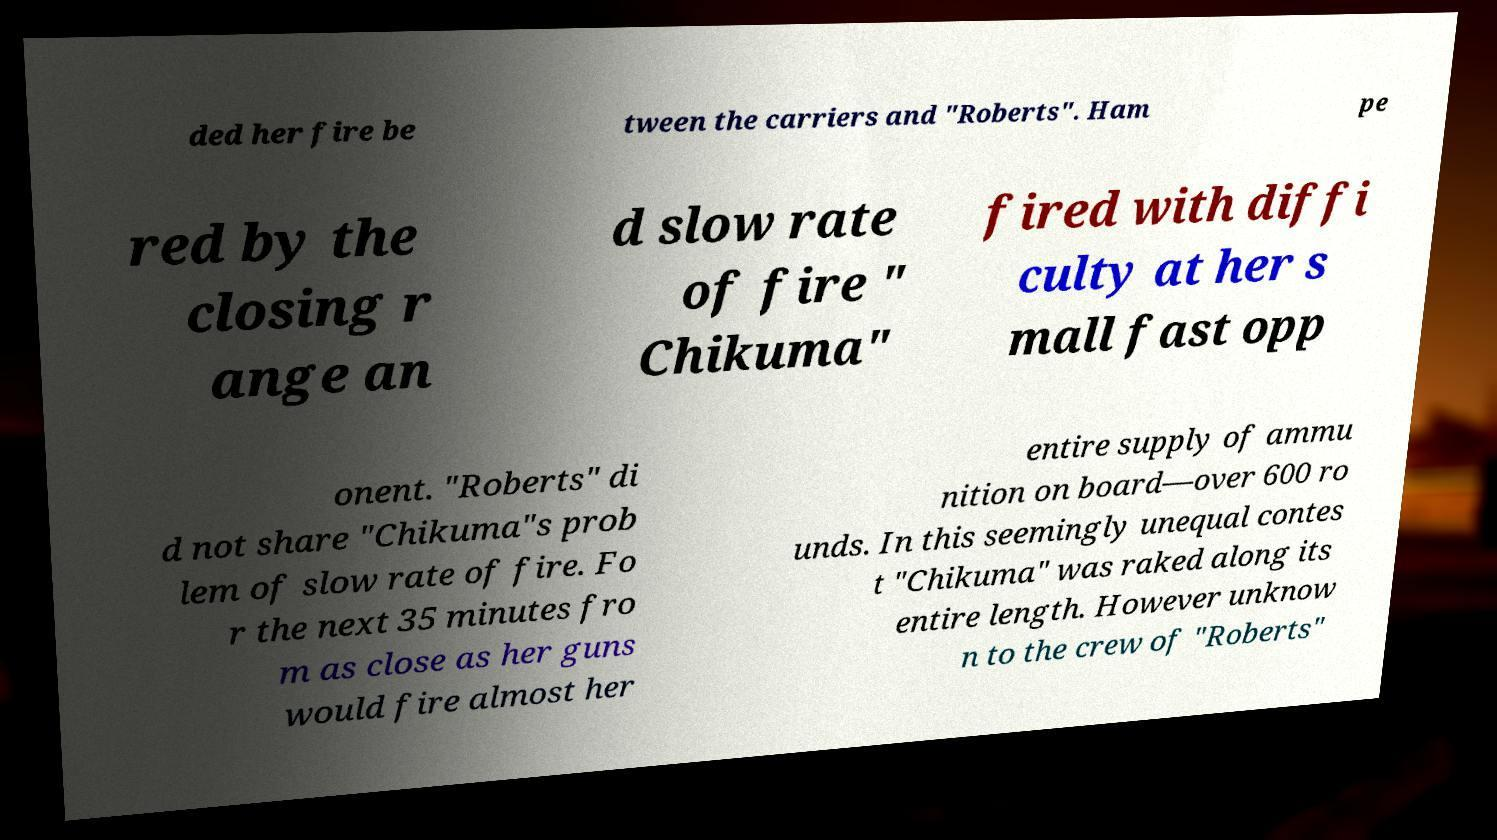There's text embedded in this image that I need extracted. Can you transcribe it verbatim? ded her fire be tween the carriers and "Roberts". Ham pe red by the closing r ange an d slow rate of fire " Chikuma" fired with diffi culty at her s mall fast opp onent. "Roberts" di d not share "Chikuma"s prob lem of slow rate of fire. Fo r the next 35 minutes fro m as close as her guns would fire almost her entire supply of ammu nition on board—over 600 ro unds. In this seemingly unequal contes t "Chikuma" was raked along its entire length. However unknow n to the crew of "Roberts" 